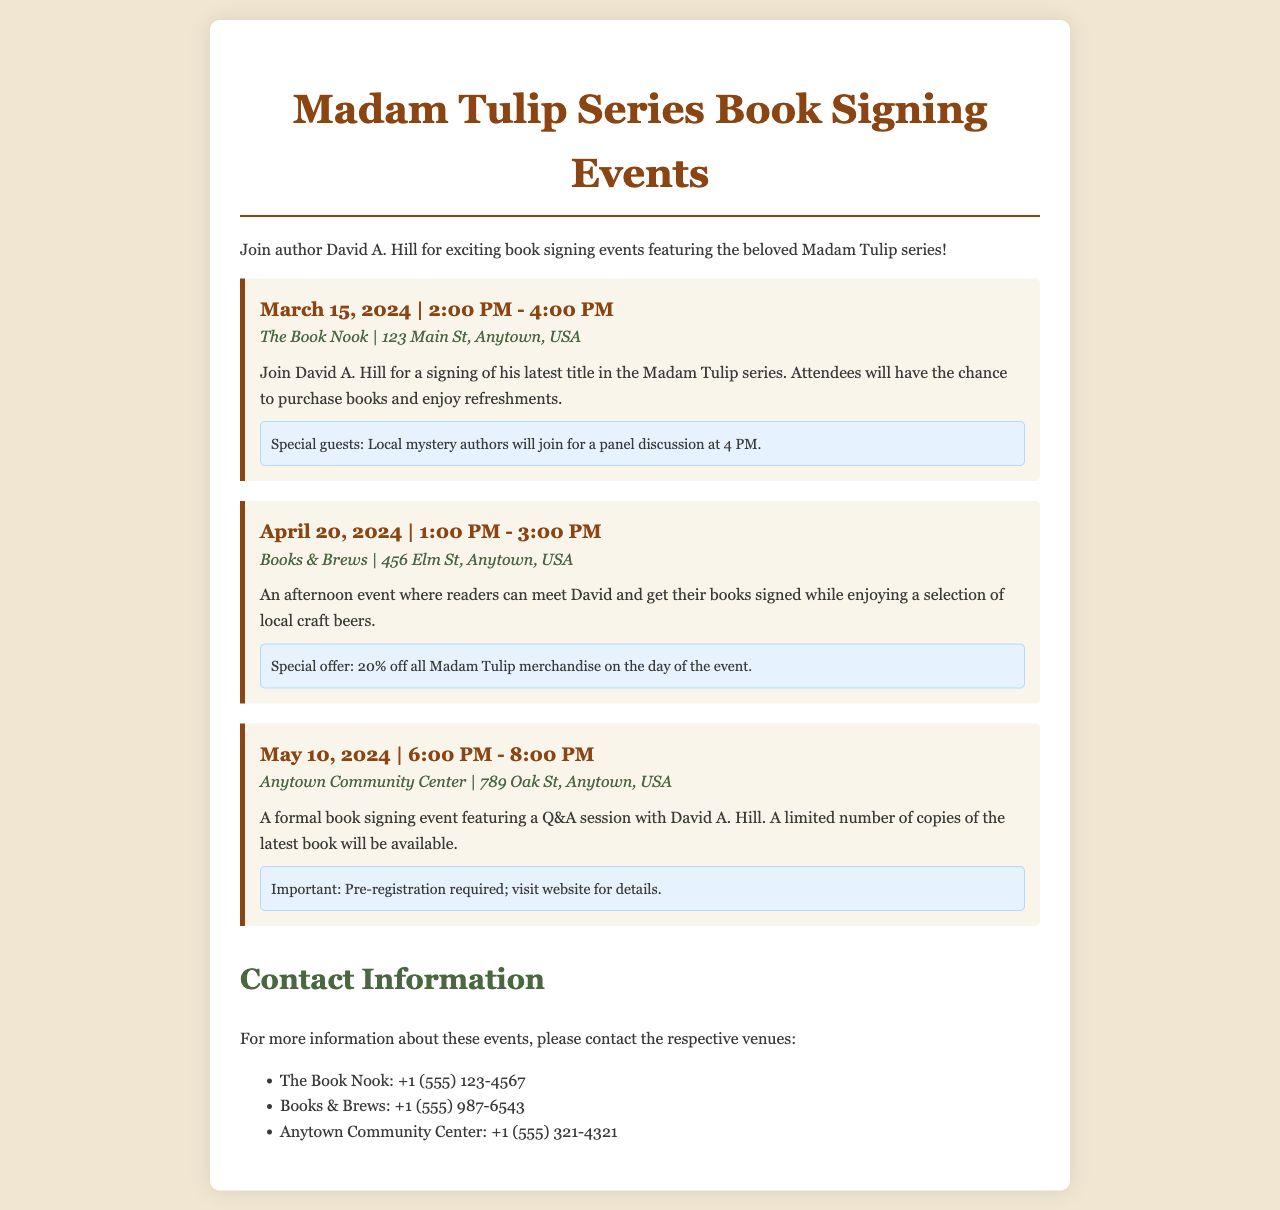What is the date of the first book signing event? The first book signing event is on March 15, 2024.
Answer: March 15, 2024 What time does the signing event at Books & Brews start? The signing event at Books & Brews starts at 1:00 PM.
Answer: 1:00 PM What is the location of the May 10, 2024 event? The location of the May 10, 2024 event is Anytown Community Center.
Answer: Anytown Community Center How long will the event on April 20, 2024 last? The event on April 20, 2024 lasts for 2 hours.
Answer: 2 hours Is pre-registration required for the May 10 event? The May 10 event mentions that pre-registration is required.
Answer: Yes What special offer is available at Books & Brews? Books & Brews offers 20% off all Madam Tulip merchandise.
Answer: 20% off Who are the special guests at the first event? The special guests at the first event are local mystery authors.
Answer: Local mystery authors What is the phone number for The Book Nook? The phone number for The Book Nook is +1 (555) 123-4567.
Answer: +1 (555) 123-4567 What is the primary activity planned for the event on May 10? The primary activity planned for the May 10 event is a Q&A session with David A. Hill.
Answer: Q&A session 